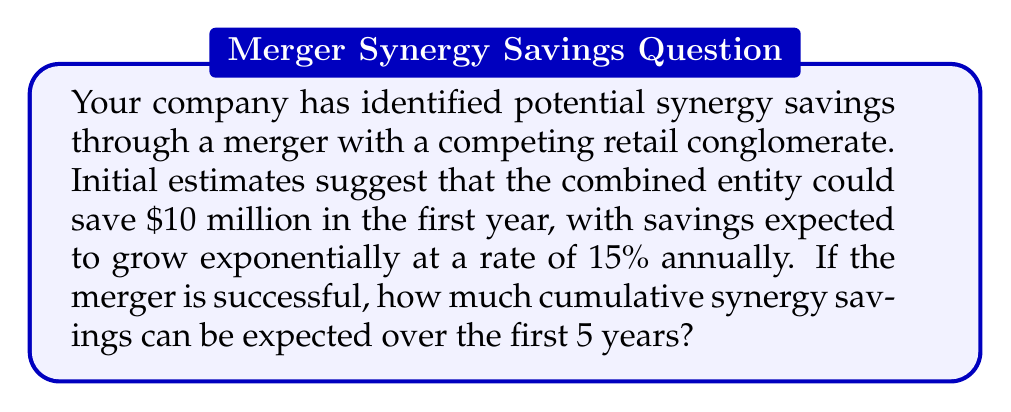Could you help me with this problem? Let's approach this step-by-step using an exponential function:

1) The general form of an exponential function is:
   $A(t) = A_0(1 + r)^t$
   Where $A_0$ is the initial amount, $r$ is the growth rate, and $t$ is time.

2) In this case:
   $A_0 = 10$ million (initial savings)
   $r = 0.15$ (15% growth rate)
   We need to calculate for $t = 1, 2, 3, 4, 5$ years

3) Let's calculate the savings for each year:

   Year 1: $A(1) = 10(1 + 0.15)^1 = 11.5$ million
   Year 2: $A(2) = 10(1 + 0.15)^2 = 13.225$ million
   Year 3: $A(3) = 10(1 + 0.15)^3 = 15.20875$ million
   Year 4: $A(4) = 10(1 + 0.15)^4 = 17.490063$ million
   Year 5: $A(5) = 10(1 + 0.15)^5 = 20.113572$ million

4) To find the cumulative savings, we sum these amounts:

   $\text{Cumulative Savings} = \sum_{t=1}^5 10(1.15)^t$

5) Adding these up:
   $11.5 + 13.225 + 15.20875 + 17.490063 + 20.113572 = 77.537385$ million

Therefore, the cumulative synergy savings over 5 years would be approximately $77.54 million.
Answer: $77.54 million 